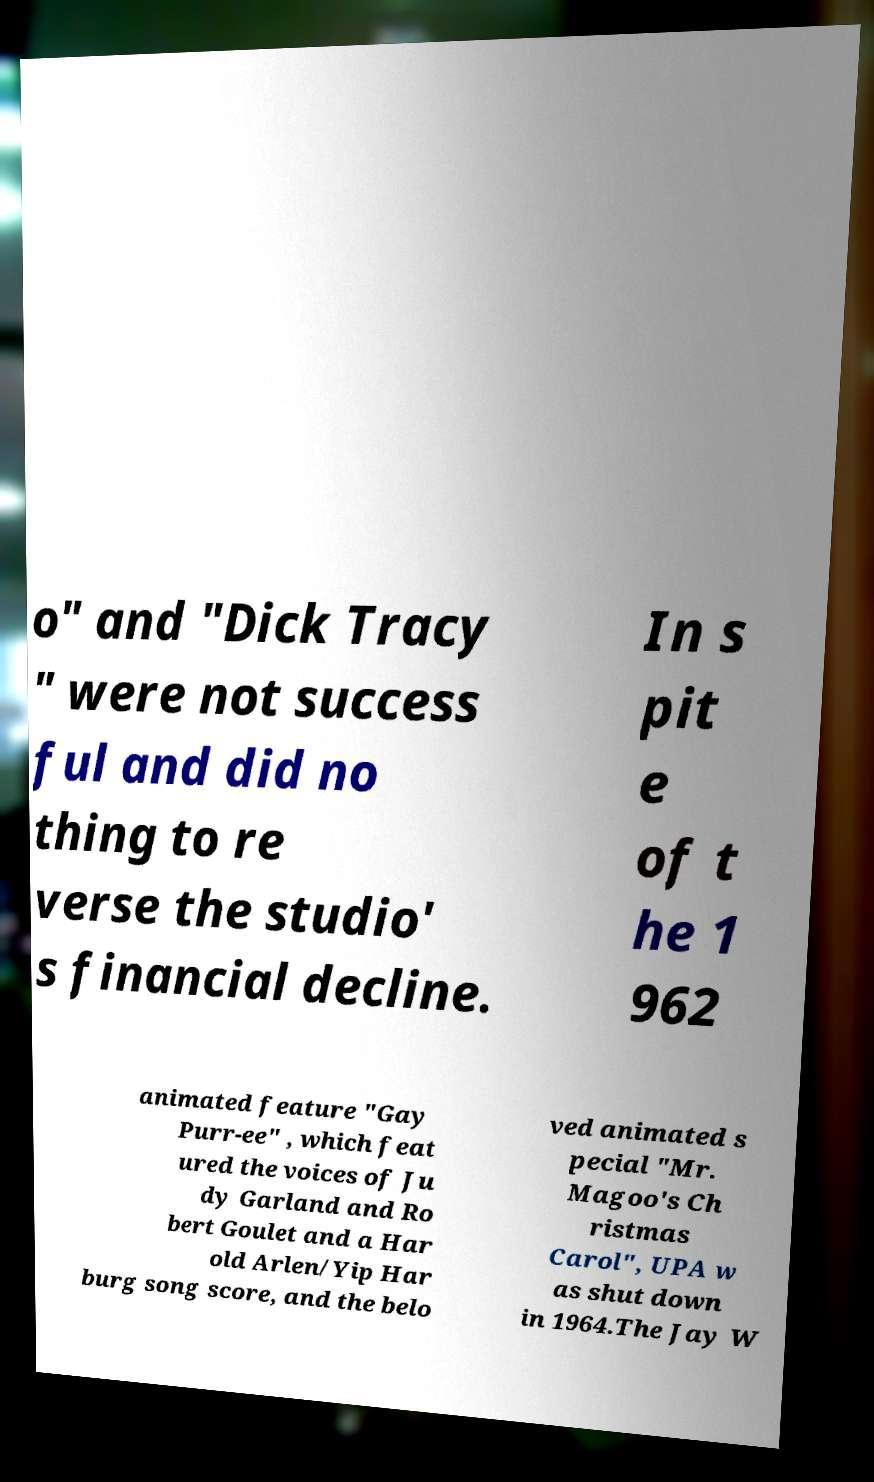Could you assist in decoding the text presented in this image and type it out clearly? o" and "Dick Tracy " were not success ful and did no thing to re verse the studio' s financial decline. In s pit e of t he 1 962 animated feature "Gay Purr-ee" , which feat ured the voices of Ju dy Garland and Ro bert Goulet and a Har old Arlen/Yip Har burg song score, and the belo ved animated s pecial "Mr. Magoo's Ch ristmas Carol", UPA w as shut down in 1964.The Jay W 